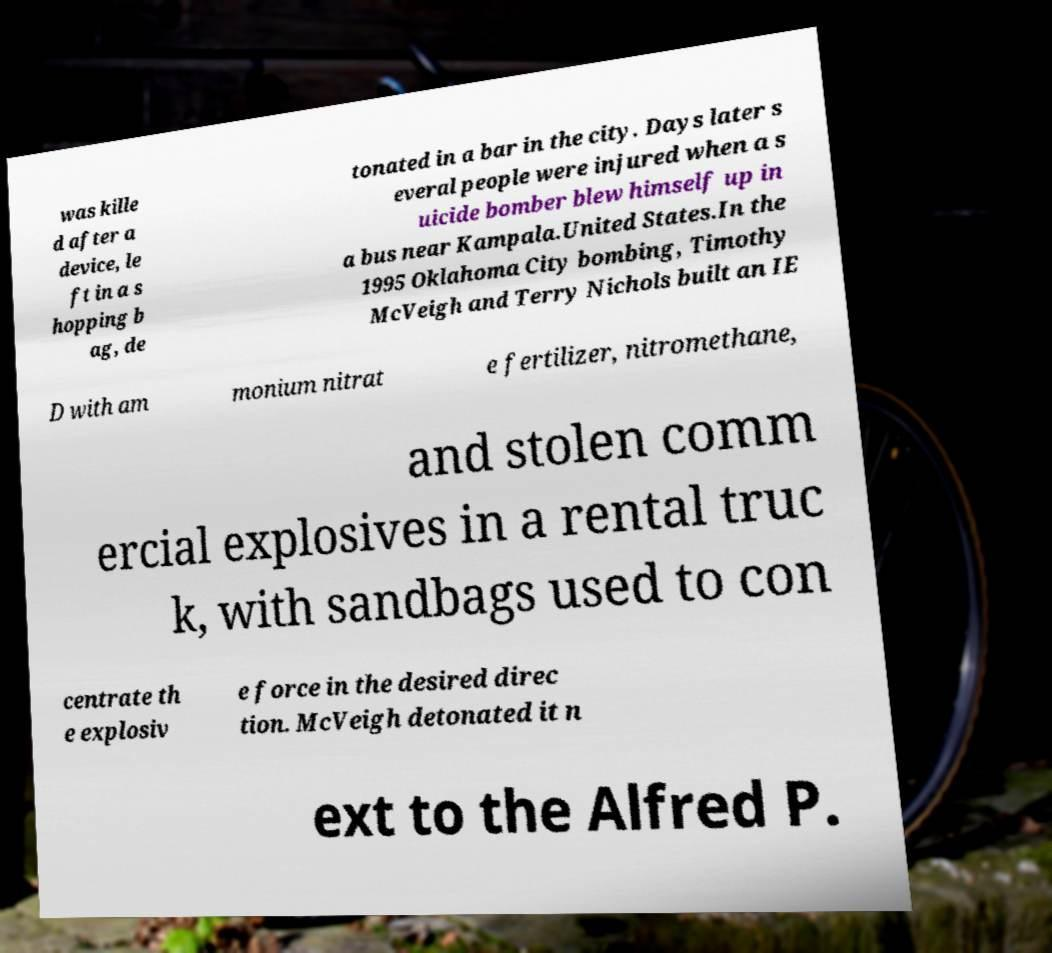Please read and relay the text visible in this image. What does it say? was kille d after a device, le ft in a s hopping b ag, de tonated in a bar in the city. Days later s everal people were injured when a s uicide bomber blew himself up in a bus near Kampala.United States.In the 1995 Oklahoma City bombing, Timothy McVeigh and Terry Nichols built an IE D with am monium nitrat e fertilizer, nitromethane, and stolen comm ercial explosives in a rental truc k, with sandbags used to con centrate th e explosiv e force in the desired direc tion. McVeigh detonated it n ext to the Alfred P. 